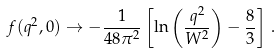<formula> <loc_0><loc_0><loc_500><loc_500>f ( q ^ { 2 } , 0 ) \rightarrow - \frac { 1 } { 4 8 \pi ^ { 2 } } \left [ \ln \left ( \frac { q ^ { 2 } } { W ^ { 2 } } \right ) - \frac { 8 } { 3 } \right ] \, .</formula> 